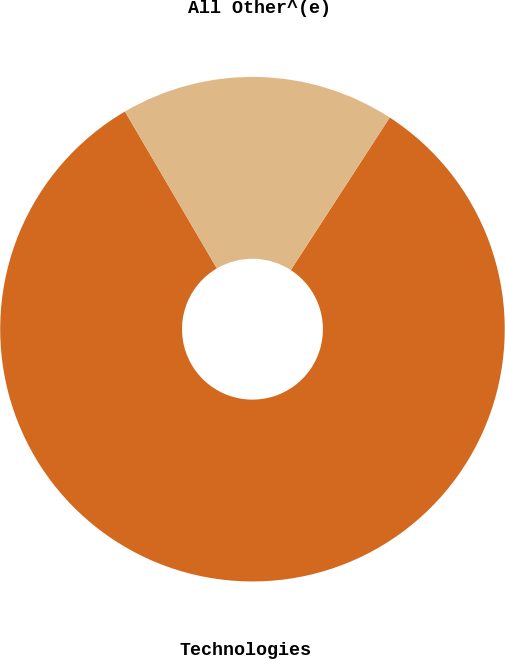Convert chart to OTSL. <chart><loc_0><loc_0><loc_500><loc_500><pie_chart><fcel>Technologies<fcel>All Other^(e)<nl><fcel>82.41%<fcel>17.59%<nl></chart> 